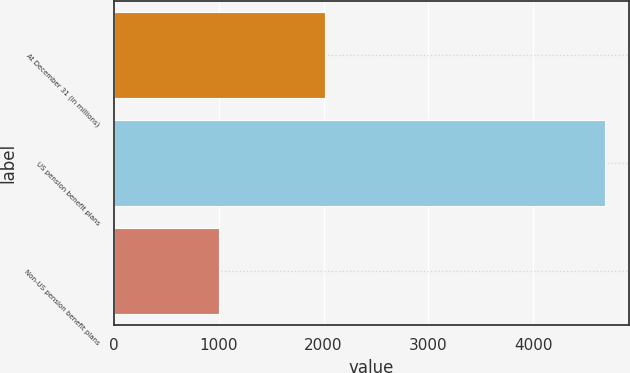<chart> <loc_0><loc_0><loc_500><loc_500><bar_chart><fcel>At December 31 (in millions)<fcel>US pension benefit plans<fcel>Non-US pension benefit plans<nl><fcel>2013<fcel>4683<fcel>1000<nl></chart> 